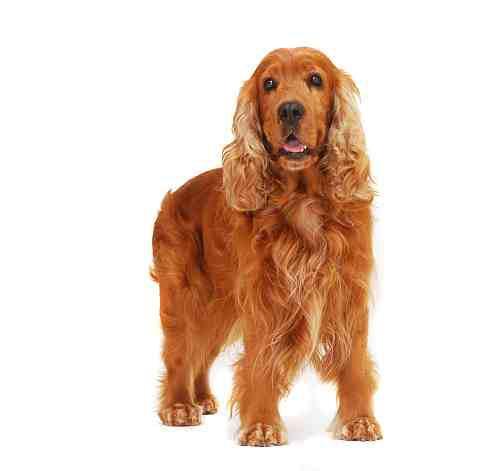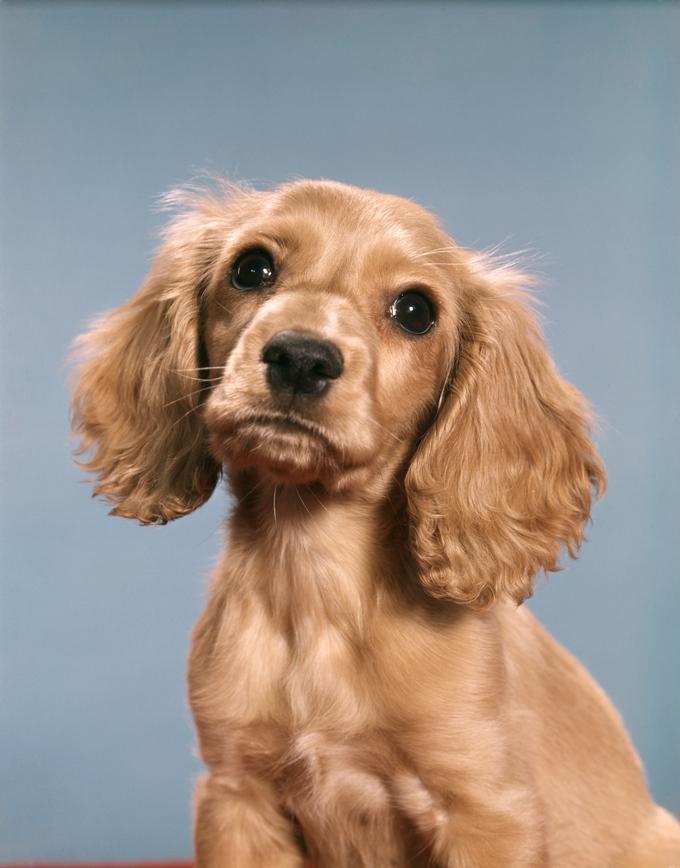The first image is the image on the left, the second image is the image on the right. Evaluate the accuracy of this statement regarding the images: "There are two dogs". Is it true? Answer yes or no. Yes. 